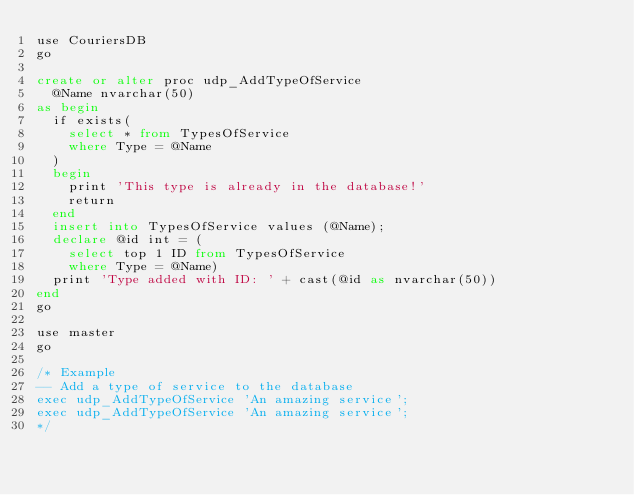Convert code to text. <code><loc_0><loc_0><loc_500><loc_500><_SQL_>use CouriersDB
go

create or alter proc udp_AddTypeOfService
	@Name nvarchar(50)
as begin
	if exists(
		select * from TypesOfService
		where Type = @Name
	)
	begin
		print 'This type is already in the database!'
		return
	end
	insert into TypesOfService values (@Name);
	declare @id int = (
		select top 1 ID from TypesOfService
		where Type = @Name)
	print 'Type added with ID: ' + cast(@id as nvarchar(50))
end
go

use master
go

/* Example
-- Add a type of service to the database
exec udp_AddTypeOfService 'An amazing service';
exec udp_AddTypeOfService 'An amazing service';
*/</code> 